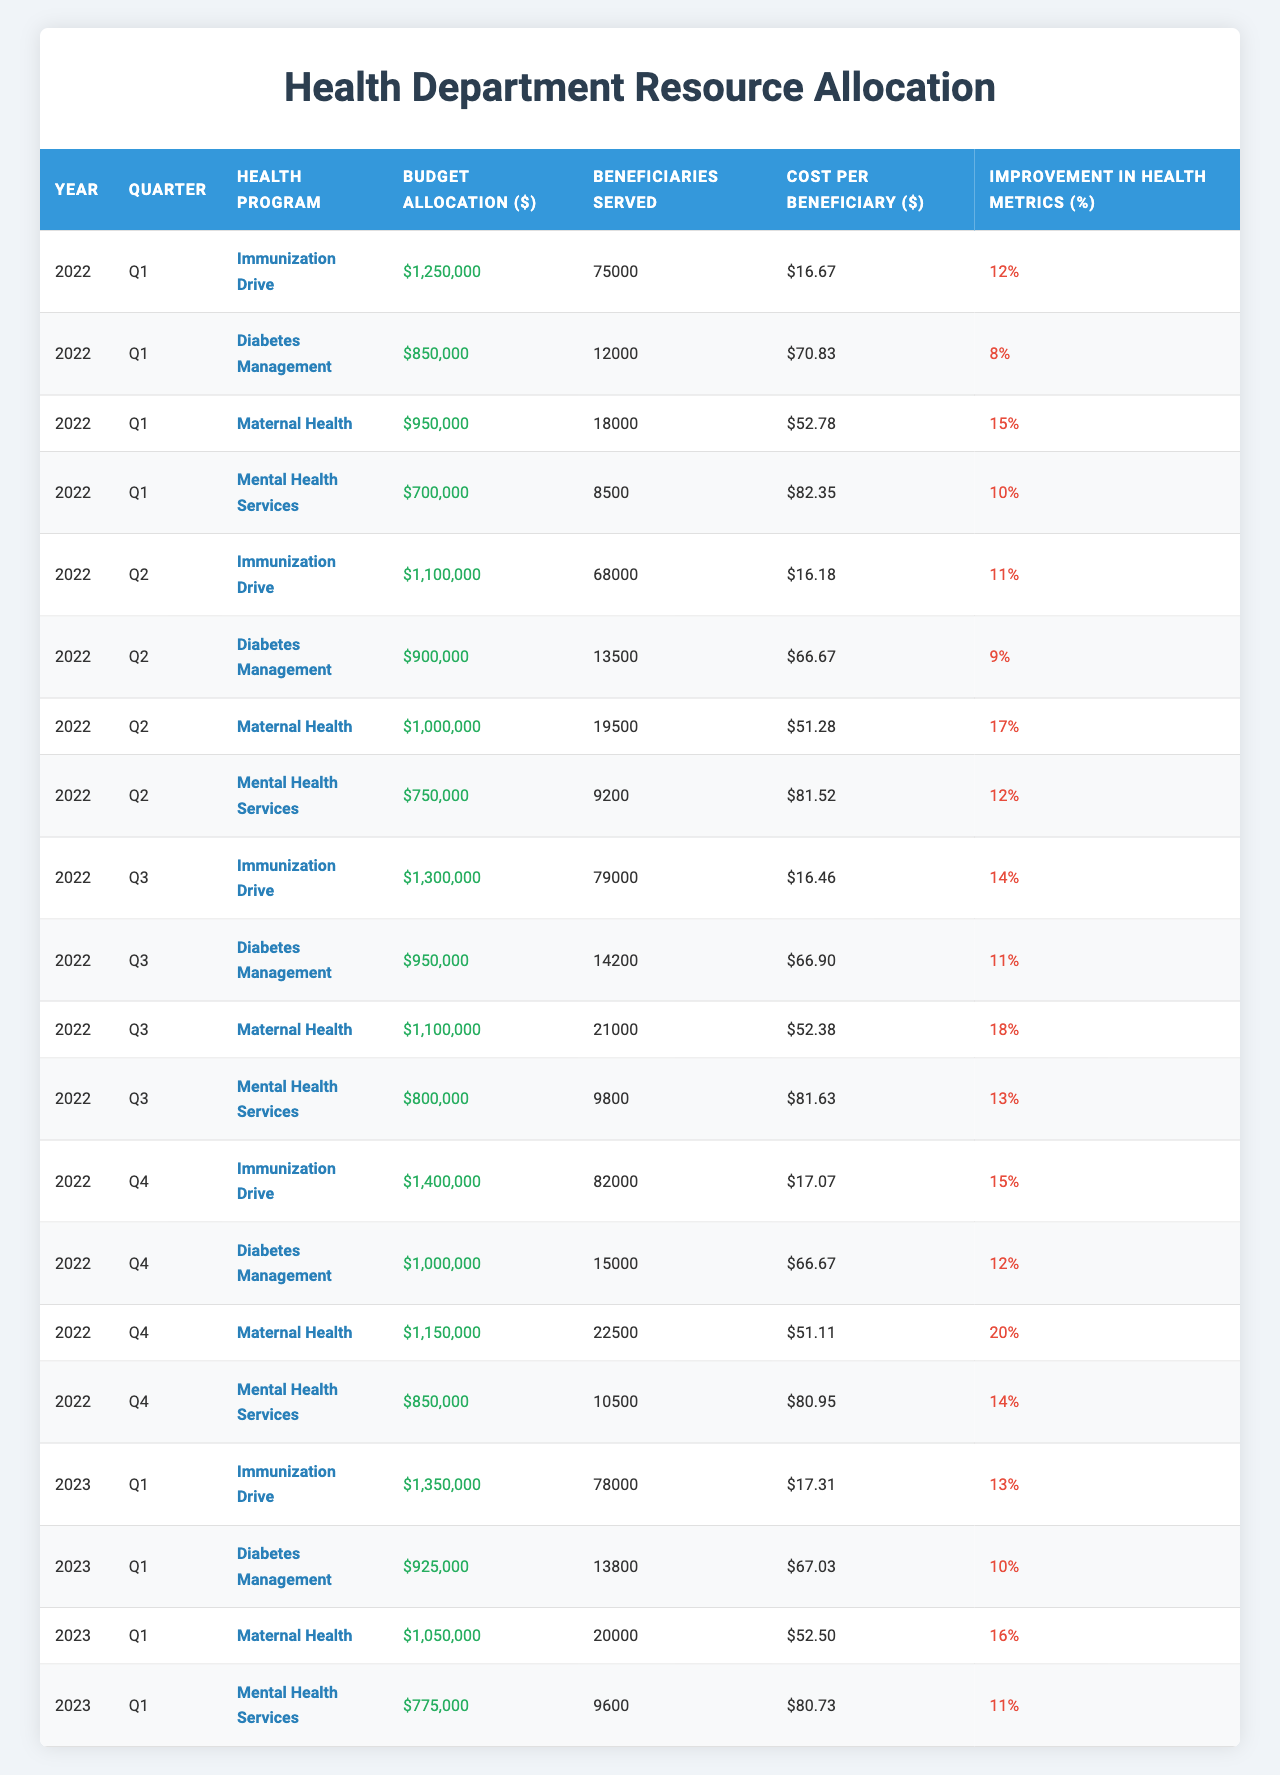What was the budget allocation for the Maternal Health program in Q3 of 2022? The table indicates that the budget allocation for Maternal Health in Q3 of 2022 is listed in the corresponding row, which shows $1,100,000.
Answer: $1,100,000 Which health program served the most beneficiaries in Q1 of 2023? In Q1 of 2023, the number of beneficiaries served for each program shows that the Immunization Drive served 78,000, while other programs served fewer beneficiaries. Thus, the Immunization Drive served the most.
Answer: Immunization Drive What is the total budget allocation for Mental Health Services over all quarters in 2022? To find the total budget allocation for Mental Health Services in 2022, sum the budget allocations across all quarters for that program: $700,000 + $750,000 + $800,000 + $850,000 = $3,300,000.
Answer: $3,300,000 Did the Improvement in Health Metrics for the Diabetes Management program increase from Q1 to Q4 in 2022? The Improvement in Health Metrics for the Diabetes Management program in Q1 was 8%, and in Q4, it was 12%. Since 12% is greater than 8%, it indicates an increase.
Answer: Yes What is the average Cost per Beneficiary across all health programs in Q2 of 2022? The cost per beneficiary for Q2 is given as 16.18 for Immunization Drive, 66.67 for Diabetes Management, 51.28 for Maternal Health, and 81.52 for Mental Health Services. To find the average, sum these values (16.18 + 66.67 + 51.28 + 81.52) = 215.65 and divide by 4, resulting in an average cost per beneficiary of 53.91.
Answer: $53.91 Which health program had the highest Improvement in Health Metrics in Q4 of 2022? By reviewing the data for Q4, it can be observed that the Maternal Health program achieved an Improvement in Health Metrics of 20%, which is higher than the others in that quarter.
Answer: Maternal Health Is the Budget Allocation for the Immunization Drive in Q1 of 2023 greater than in Q1 of 2022? The budget for the Immunization Drive in Q1 of 2023 was $1,350,000, while in Q1 of 2022 it was $1,250,000. Thus, $1,350,000 is greater than $1,250,000, confirming the statement.
Answer: Yes What was the total number of beneficiaries served by the Diabetes Management program across all quarters in 2022? The beneficiaries served in 2022 were 12,000 in Q1, 13,500 in Q2, 14,200 in Q3, and 15,000 in Q4. Summing these gives (12,000 + 13,500 + 14,200 + 15,000 = 54,700).
Answer: 54,700 Is the cost per beneficiary of the Maternal Health program in Q3 of 2022 lower than that in Q1 of 2022? The cost per beneficiary for Maternal Health is $52.38 in Q3 and $52.78 in Q1. Since $52.38 is less than $52.78, it indicates that the cost has decreased.
Answer: Yes What is the total budget allocation for all health programs in Q2 of 2022? The total budget allocation in Q2 can be calculated by summing the allocations for all programs: Immunization Drive ($1,100,000) + Diabetes Management ($900,000) + Maternal Health ($1,000,000) + Mental Health Services ($750,000) = $3,750,000.
Answer: $3,750,000 What percentage increase in Improvement in Health Metrics did the Immunization Drive experience from Q1 to Q4 of 2022? The Improvement in Health Metrics for the Immunization Drive was 12% in Q1 and 15% in Q4. The percentage increase is calculated as ((15 - 12) / 12) * 100 = 25%.
Answer: 25% 